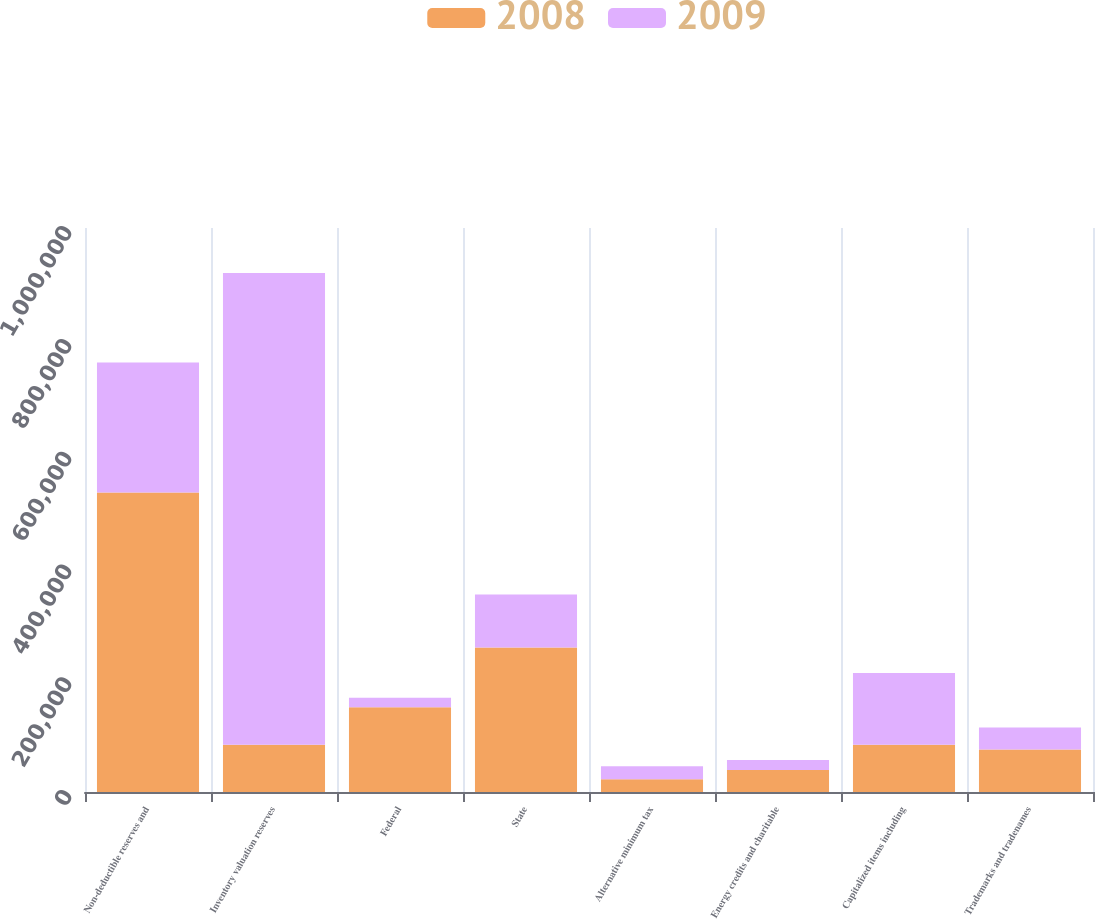<chart> <loc_0><loc_0><loc_500><loc_500><stacked_bar_chart><ecel><fcel>Non-deductible reserves and<fcel>Inventory valuation reserves<fcel>Federal<fcel>State<fcel>Alternative minimum tax<fcel>Energy credits and charitable<fcel>Capitalized items including<fcel>Trademarks and tradenames<nl><fcel>2008<fcel>531237<fcel>83880<fcel>150267<fcel>256257<fcel>22784<fcel>39053<fcel>83880<fcel>75218<nl><fcel>2009<fcel>230159<fcel>836145<fcel>16897<fcel>94100<fcel>22856<fcel>17715<fcel>127228<fcel>38971<nl></chart> 